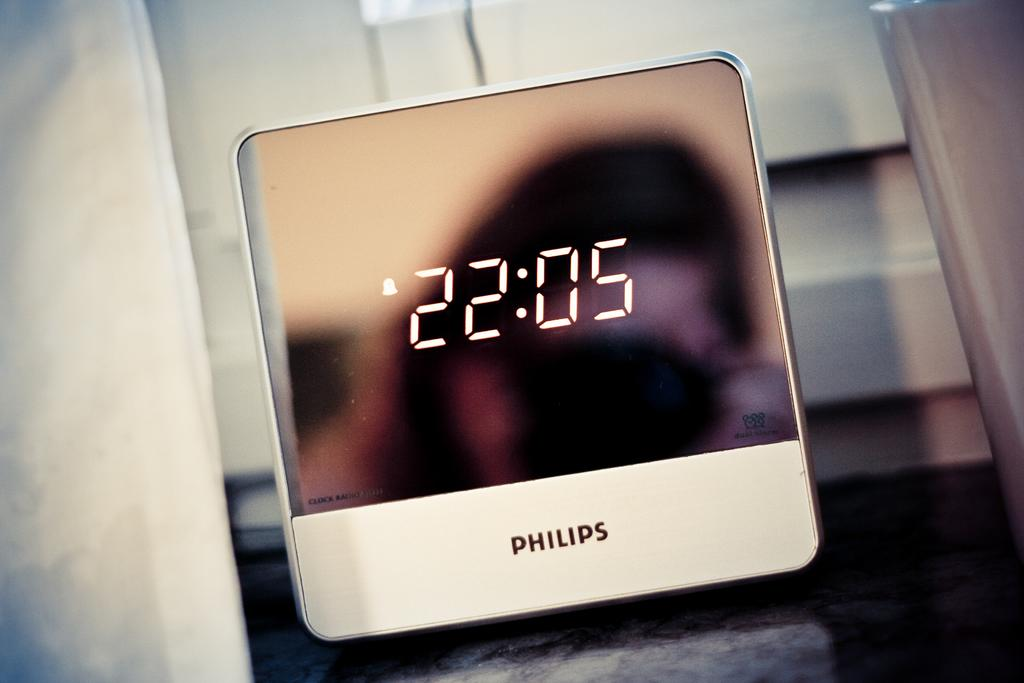<image>
Render a clear and concise summary of the photo. A digital Philips clock sits on a table and shows that the time is 22:05. 